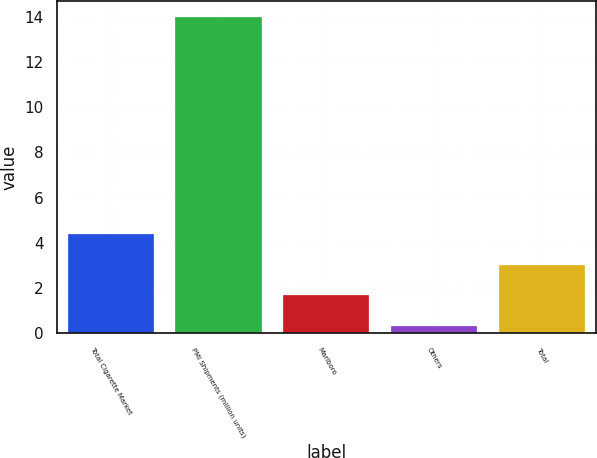<chart> <loc_0><loc_0><loc_500><loc_500><bar_chart><fcel>Total Cigarette Market<fcel>PMI Shipments (million units)<fcel>Marlboro<fcel>Others<fcel>Total<nl><fcel>4.41<fcel>14<fcel>1.67<fcel>0.3<fcel>3.04<nl></chart> 